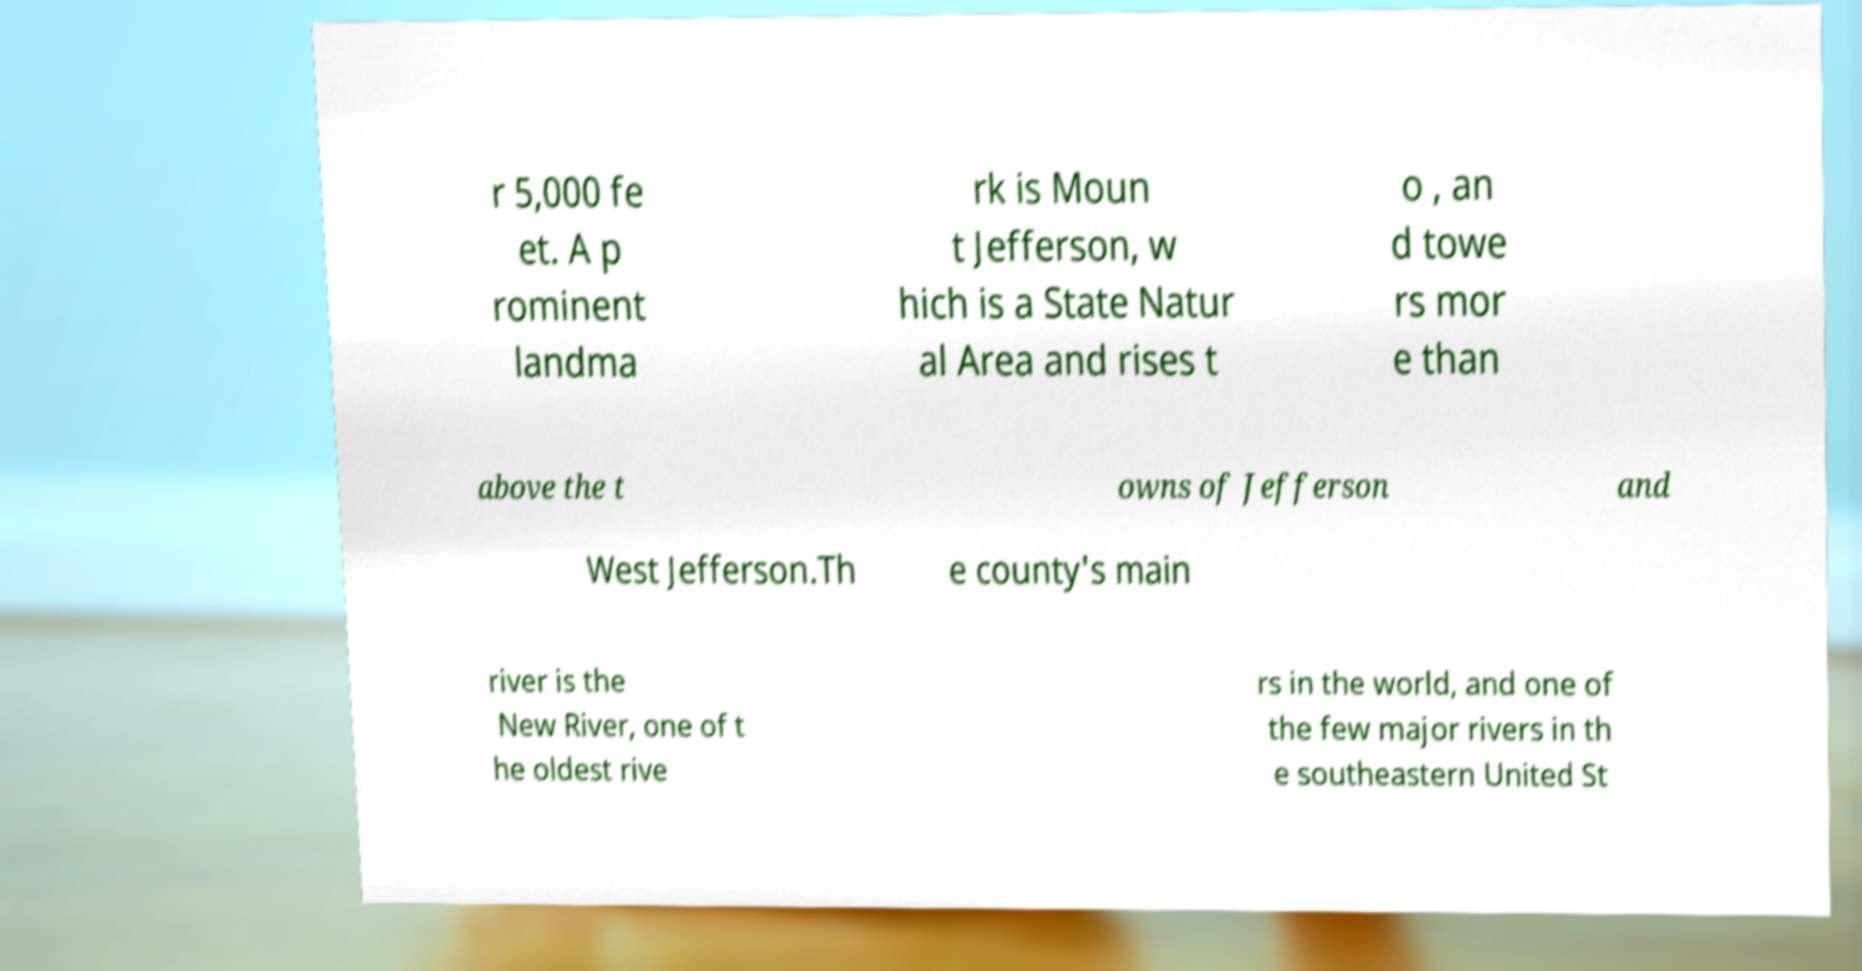Can you read and provide the text displayed in the image?This photo seems to have some interesting text. Can you extract and type it out for me? r 5,000 fe et. A p rominent landma rk is Moun t Jefferson, w hich is a State Natur al Area and rises t o , an d towe rs mor e than above the t owns of Jefferson and West Jefferson.Th e county's main river is the New River, one of t he oldest rive rs in the world, and one of the few major rivers in th e southeastern United St 